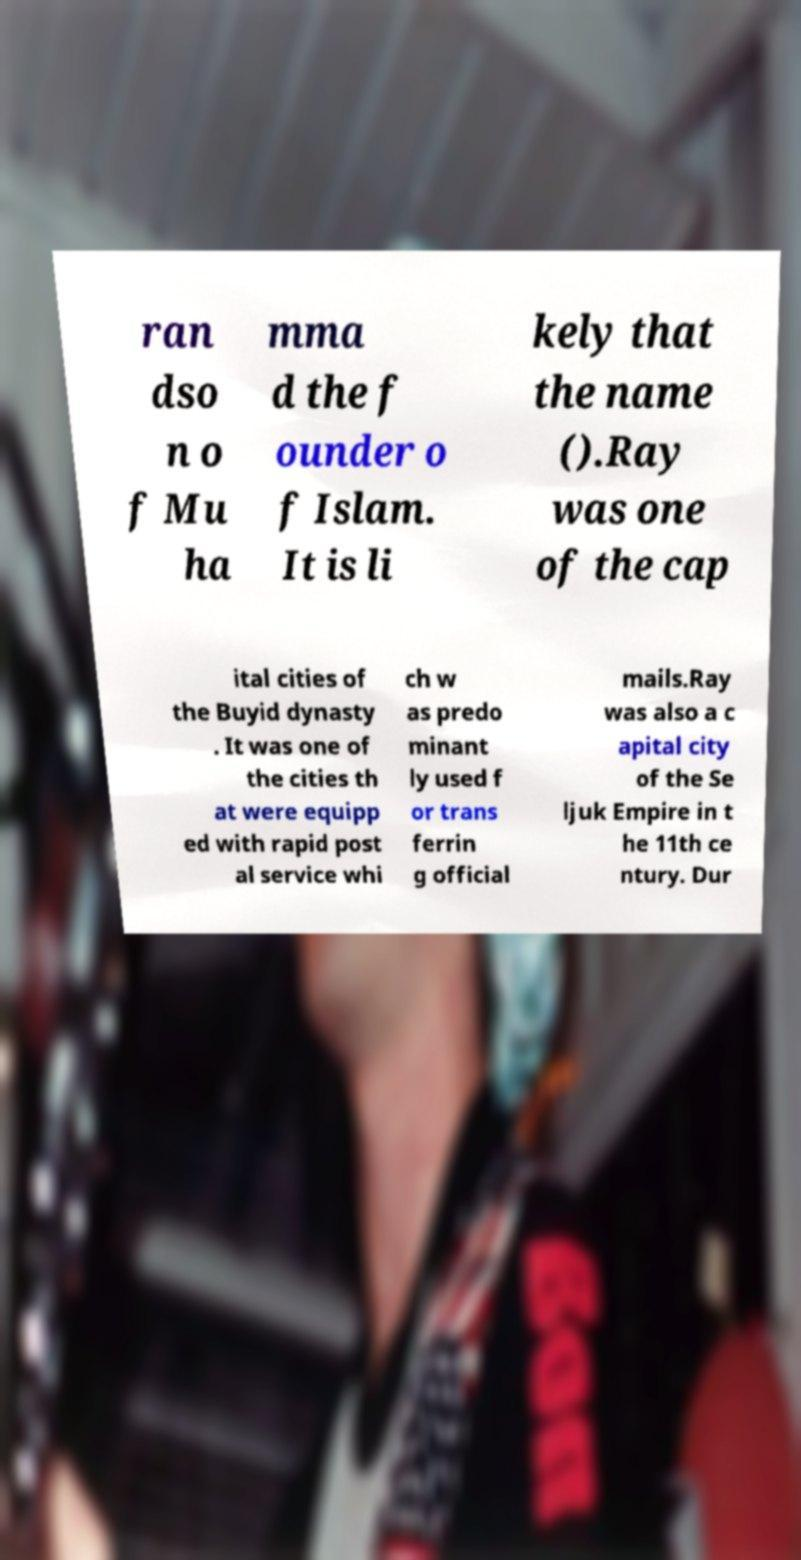For documentation purposes, I need the text within this image transcribed. Could you provide that? ran dso n o f Mu ha mma d the f ounder o f Islam. It is li kely that the name ().Ray was one of the cap ital cities of the Buyid dynasty . It was one of the cities th at were equipp ed with rapid post al service whi ch w as predo minant ly used f or trans ferrin g official mails.Ray was also a c apital city of the Se ljuk Empire in t he 11th ce ntury. Dur 